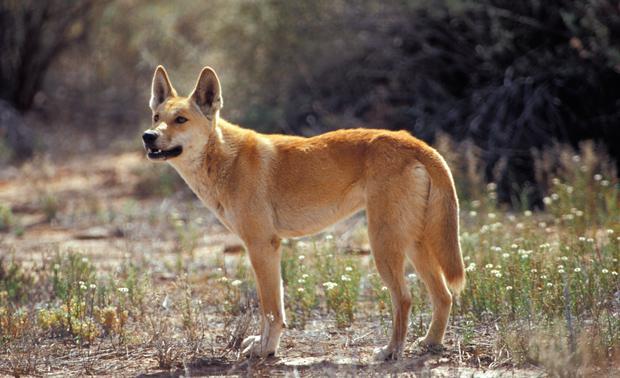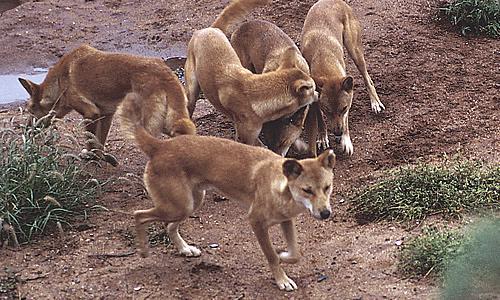The first image is the image on the left, the second image is the image on the right. Examine the images to the left and right. Is the description "There are more dogs in the right image than in the left." accurate? Answer yes or no. Yes. The first image is the image on the left, the second image is the image on the right. Analyze the images presented: Is the assertion "One animal is standing in the image on the left." valid? Answer yes or no. Yes. 